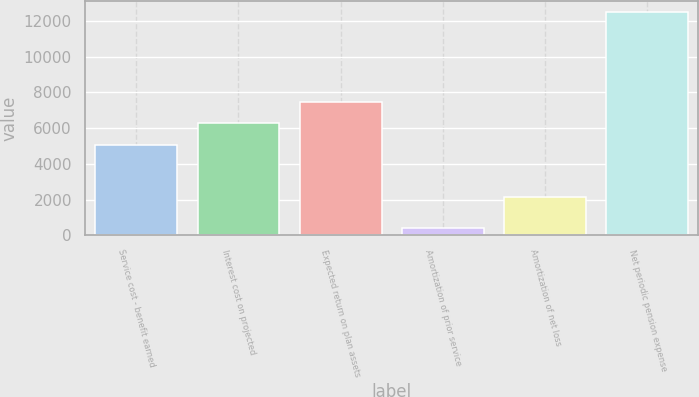Convert chart. <chart><loc_0><loc_0><loc_500><loc_500><bar_chart><fcel>Service cost - benefit earned<fcel>Interest cost on projected<fcel>Expected return on plan assets<fcel>Amortization of prior service<fcel>Amortization of net loss<fcel>Net periodic pension expense<nl><fcel>5070<fcel>6280.7<fcel>7491.4<fcel>390<fcel>2126<fcel>12497<nl></chart> 